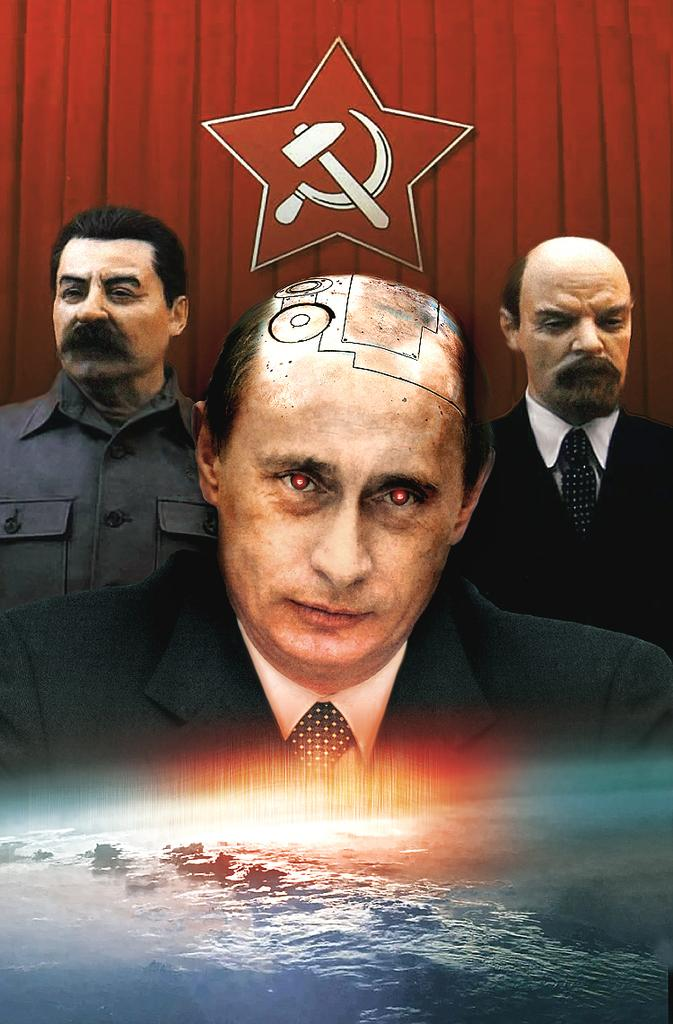What is the main subject of the image? The main subject of the image is an edited picture of three persons. What color is the background of the image? The background of the image is red. Can you identify any additional elements in the image? Yes, there is a logo and water visible at the bottom of the image. Where is the giraffe located in the image? There is no giraffe present in the image. What type of calculator can be seen in the image? There is no calculator present in the image. 